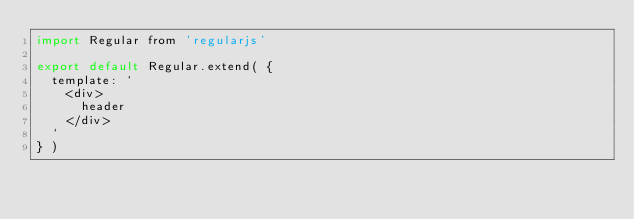<code> <loc_0><loc_0><loc_500><loc_500><_JavaScript_>import Regular from 'regularjs'

export default Regular.extend( {
	template: `
		<div>
			header
		</div>
	`
} )
</code> 